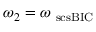Convert formula to latex. <formula><loc_0><loc_0><loc_500><loc_500>\omega _ { 2 } = \omega _ { \ s c s { B I C } }</formula> 